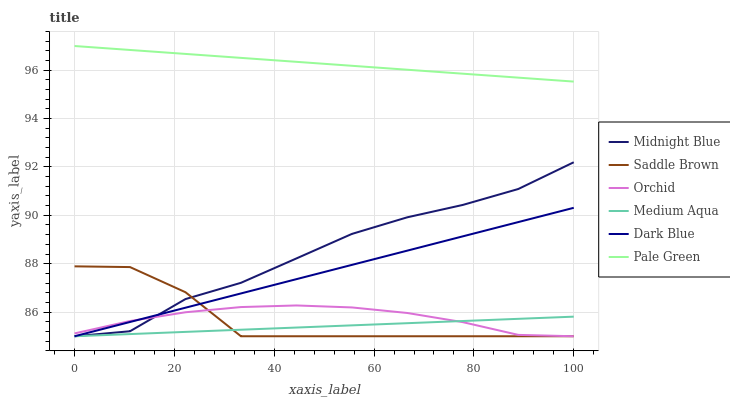Does Dark Blue have the minimum area under the curve?
Answer yes or no. No. Does Dark Blue have the maximum area under the curve?
Answer yes or no. No. Is Dark Blue the smoothest?
Answer yes or no. No. Is Dark Blue the roughest?
Answer yes or no. No. Does Pale Green have the lowest value?
Answer yes or no. No. Does Dark Blue have the highest value?
Answer yes or no. No. Is Orchid less than Pale Green?
Answer yes or no. Yes. Is Pale Green greater than Midnight Blue?
Answer yes or no. Yes. Does Orchid intersect Pale Green?
Answer yes or no. No. 